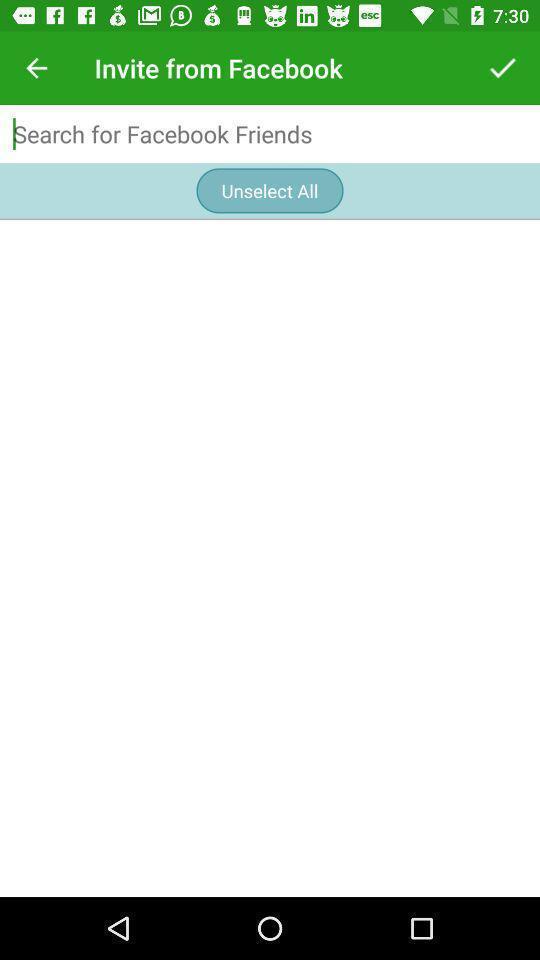What can you discern from this picture? Page displaying to search friends in social app. 